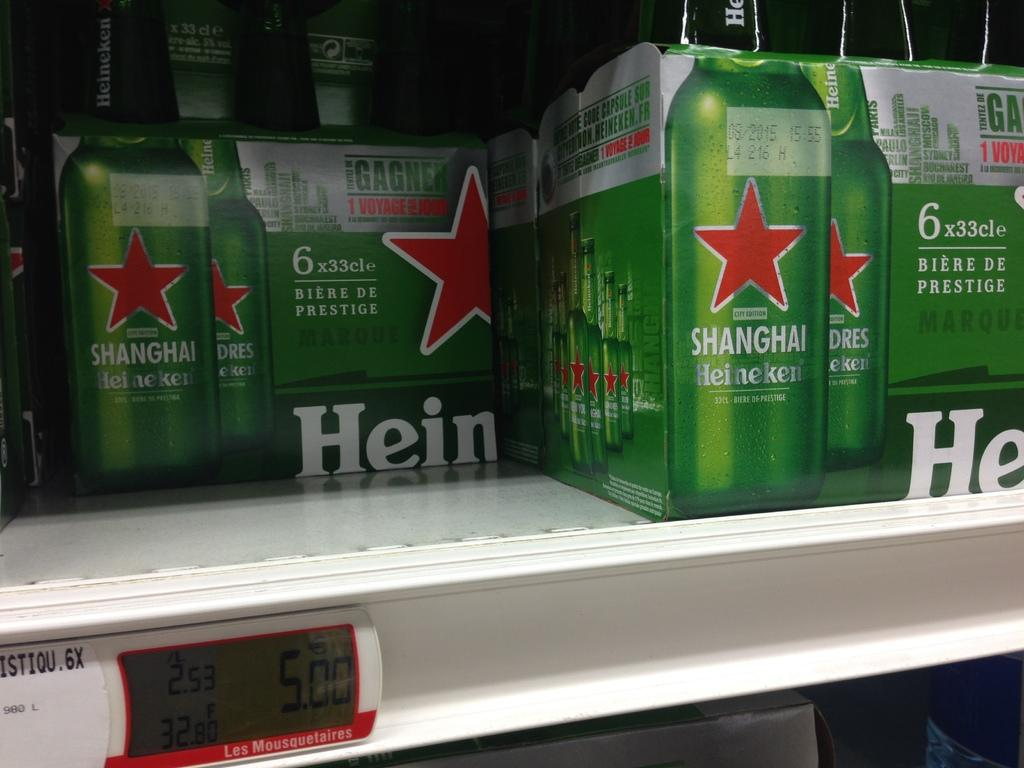Provide a one-sentence caption for the provided image. Two cases of Shanghai Heineken are on a store shelf.. 